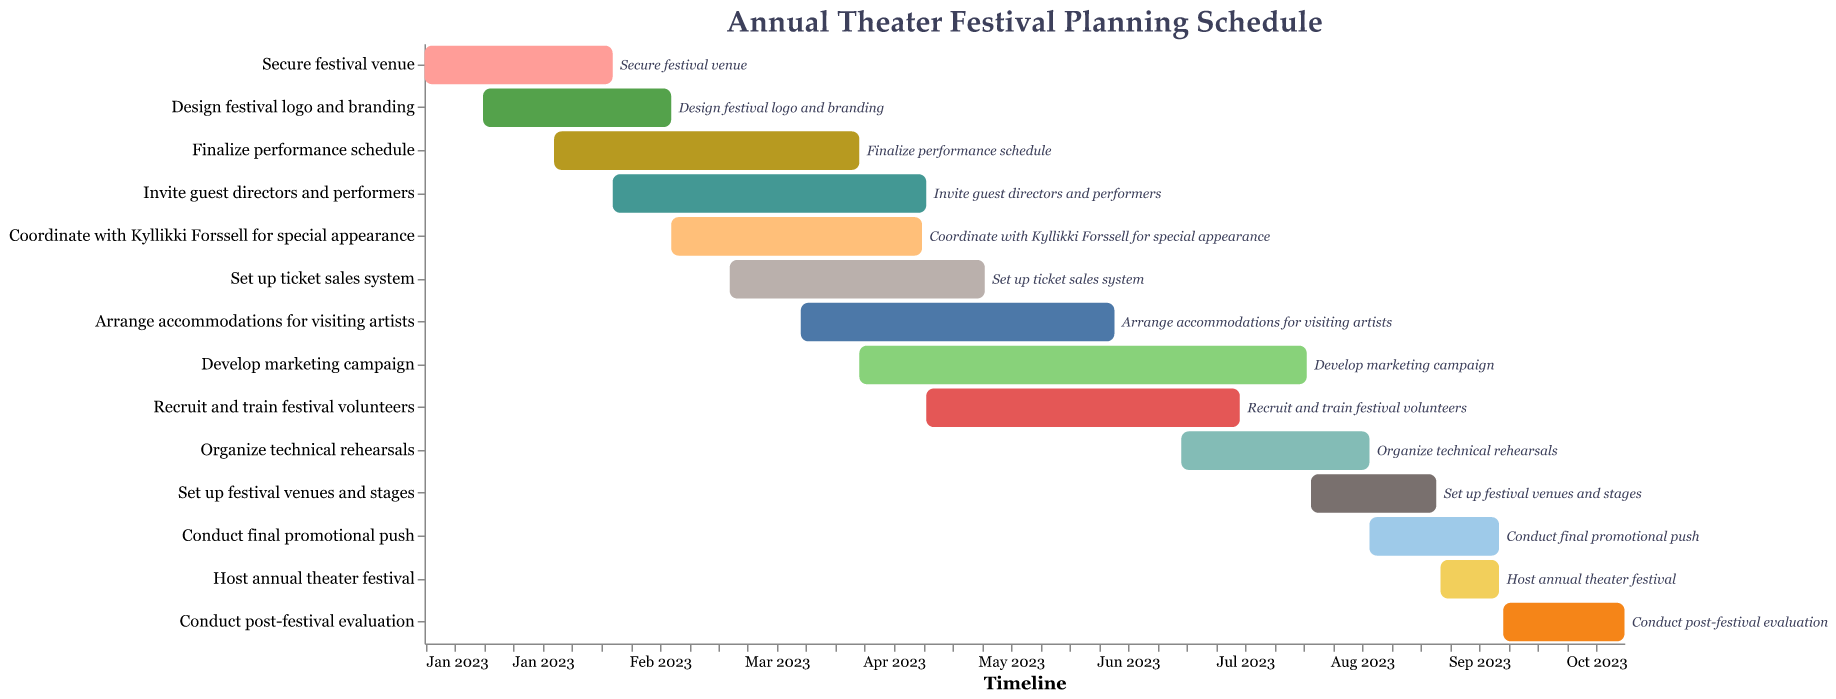What is the title of the figure? The title of the figure is displayed at the top of the chart. This can be directly read from the visual information.
Answer: Annual Theater Festival Planning Schedule What is the duration of the 'Develop marketing campaign' task? To find the duration of the 'Develop marketing campaign' task, look at its start and end dates: April 15, 2023, to July 31, 2023. Count the number of days in this range. From April 15 to July 31, it spans 3 full months and 16 days.
Answer: 3.5 months Which task starts first? To determine which task starts first, look at the start dates of all tasks. The first task starting on January 1, 2023, is 'Secure festival venue'.
Answer: Secure festival venue How many tasks are assigned during the month of April 2023? Identify all tasks that start or end in April 2023 from the figure. These tasks are 'Finalize performance schedule,' 'Coordinate with Kyllikki Forssell for special appearance,' 'Set up ticket sales system,' 'Arrange accommodations for visiting artists,' and 'Develop marketing campaign.' Count them.
Answer: 5 tasks Are there any tasks that overlap with the 'Invite guest directors and performers'? Identify the start and end date of the 'Invite guest directors and performers' task and compare it to the other tasks' time frames. This task runs from February 15, 2023, to May 1, 2023. Tasks overlapping include 'Finalize performance schedule,' 'Coordinate with Kyllikki Forssell for special appearance,' and 'Set up ticket sales system.'
Answer: Yes How long after the 'Secure festival venue' task does 'Develop marketing campaign' begin? To determine the gap between the end of 'Secure festival venue' (February 15, 2023) and the start of 'Develop marketing campaign' (April 15, 2023), calculate the time difference. The difference is 2 months.
Answer: 2 months Compare the duration of 'Organize technical rehearsals' with 'Conduct final promotional push.' Which one is longer? For 'Organize technical rehearsals,' span is from July 1, 2023, to August 15, 2023 (1.5 months). For 'Conduct final promotional push,' span is from August 15, 2023, to September 15, 2023 (1 month). Compare these durations.
Answer: Organize technical rehearsals What tasks are executed simultaneously with the 'Set up ticket sales system'? Look at the time frame of 'Set up ticket sales system' (March 15, 2023, to May 15, 2023) and identify the tasks that overlap with it. These include 'Finalize performance schedule,' 'Invite guest directors and performers,' 'Coordinate with Kyllikki Forssell for special appearance,' and 'Arrange accommodations for visiting artists.'
Answer: 4 tasks 